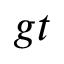Convert formula to latex. <formula><loc_0><loc_0><loc_500><loc_500>g t</formula> 